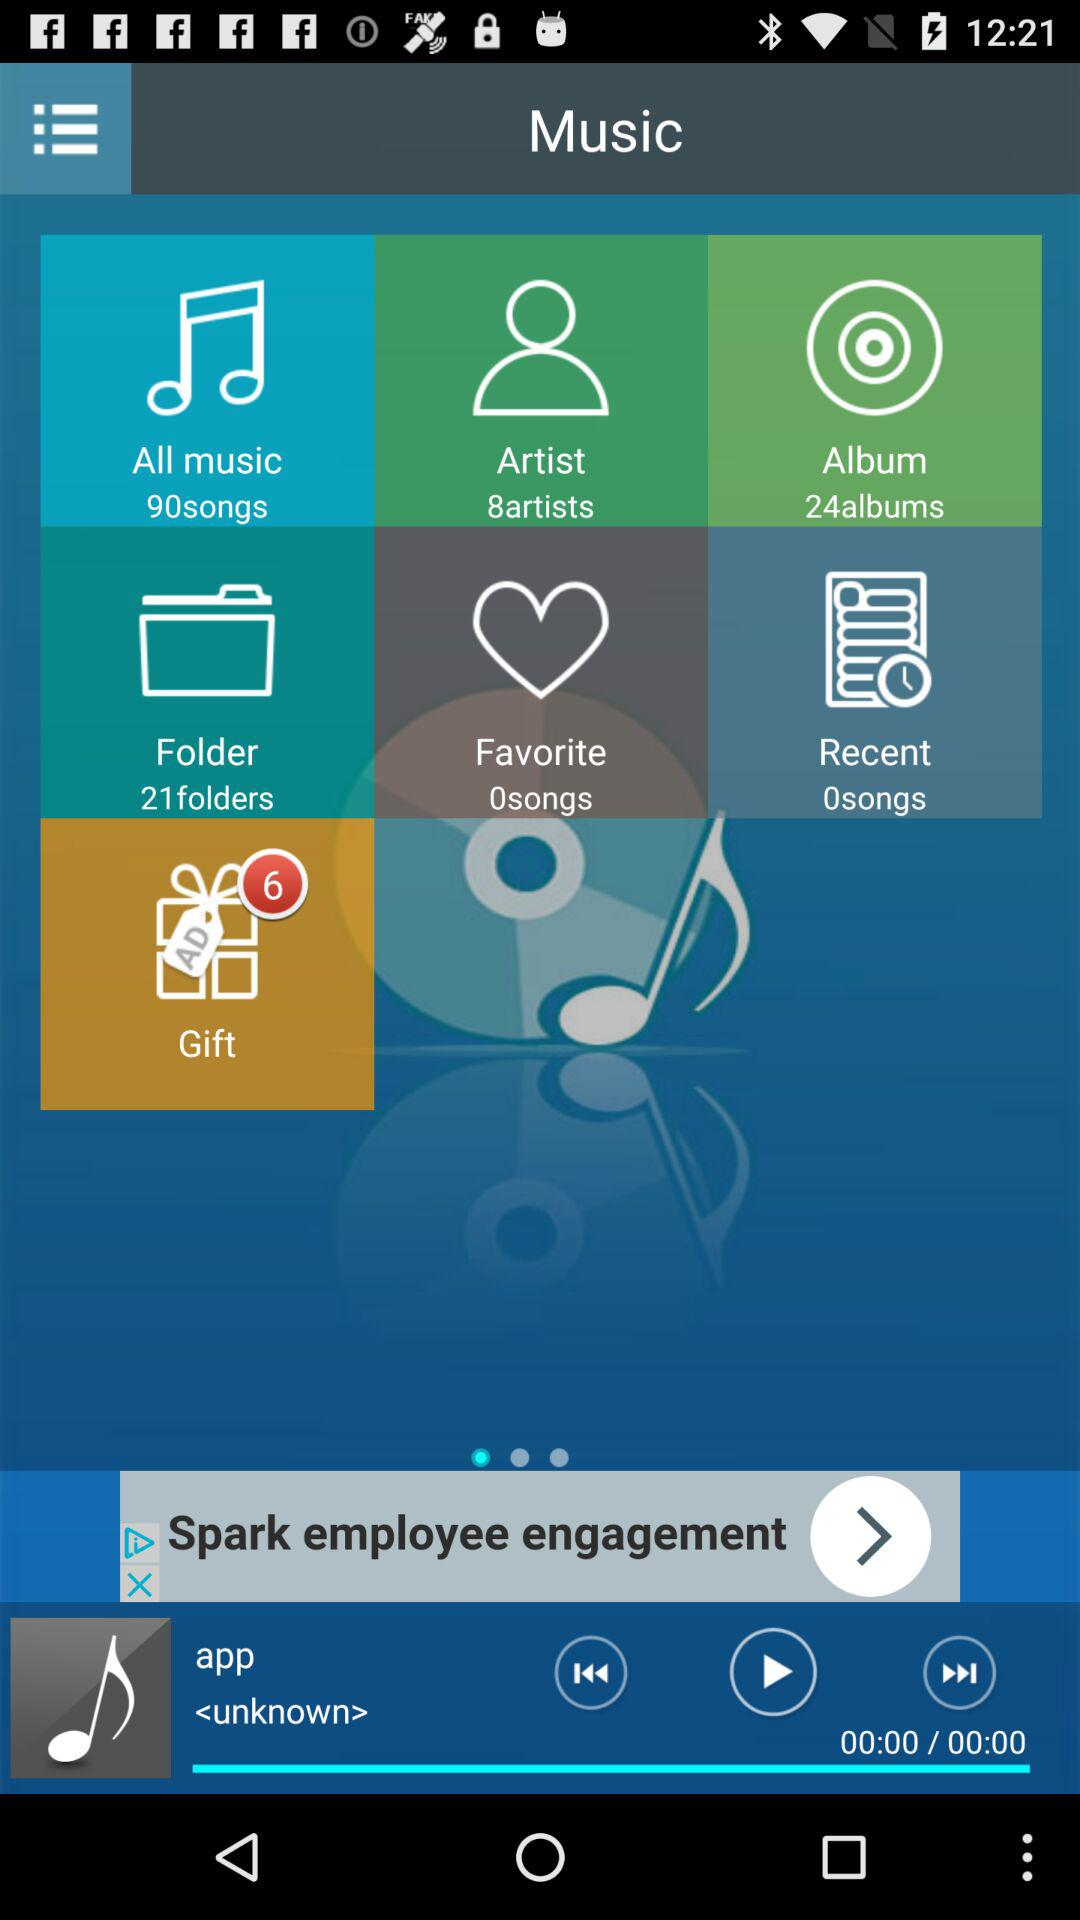24 files present in which folder?
When the provided information is insufficient, respond with <no answer>. <no answer> 